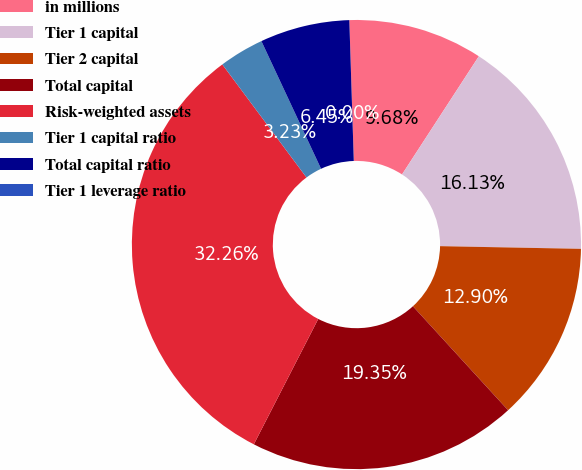Convert chart to OTSL. <chart><loc_0><loc_0><loc_500><loc_500><pie_chart><fcel>in millions<fcel>Tier 1 capital<fcel>Tier 2 capital<fcel>Total capital<fcel>Risk-weighted assets<fcel>Tier 1 capital ratio<fcel>Total capital ratio<fcel>Tier 1 leverage ratio<nl><fcel>9.68%<fcel>16.13%<fcel>12.9%<fcel>19.35%<fcel>32.26%<fcel>3.23%<fcel>6.45%<fcel>0.0%<nl></chart> 